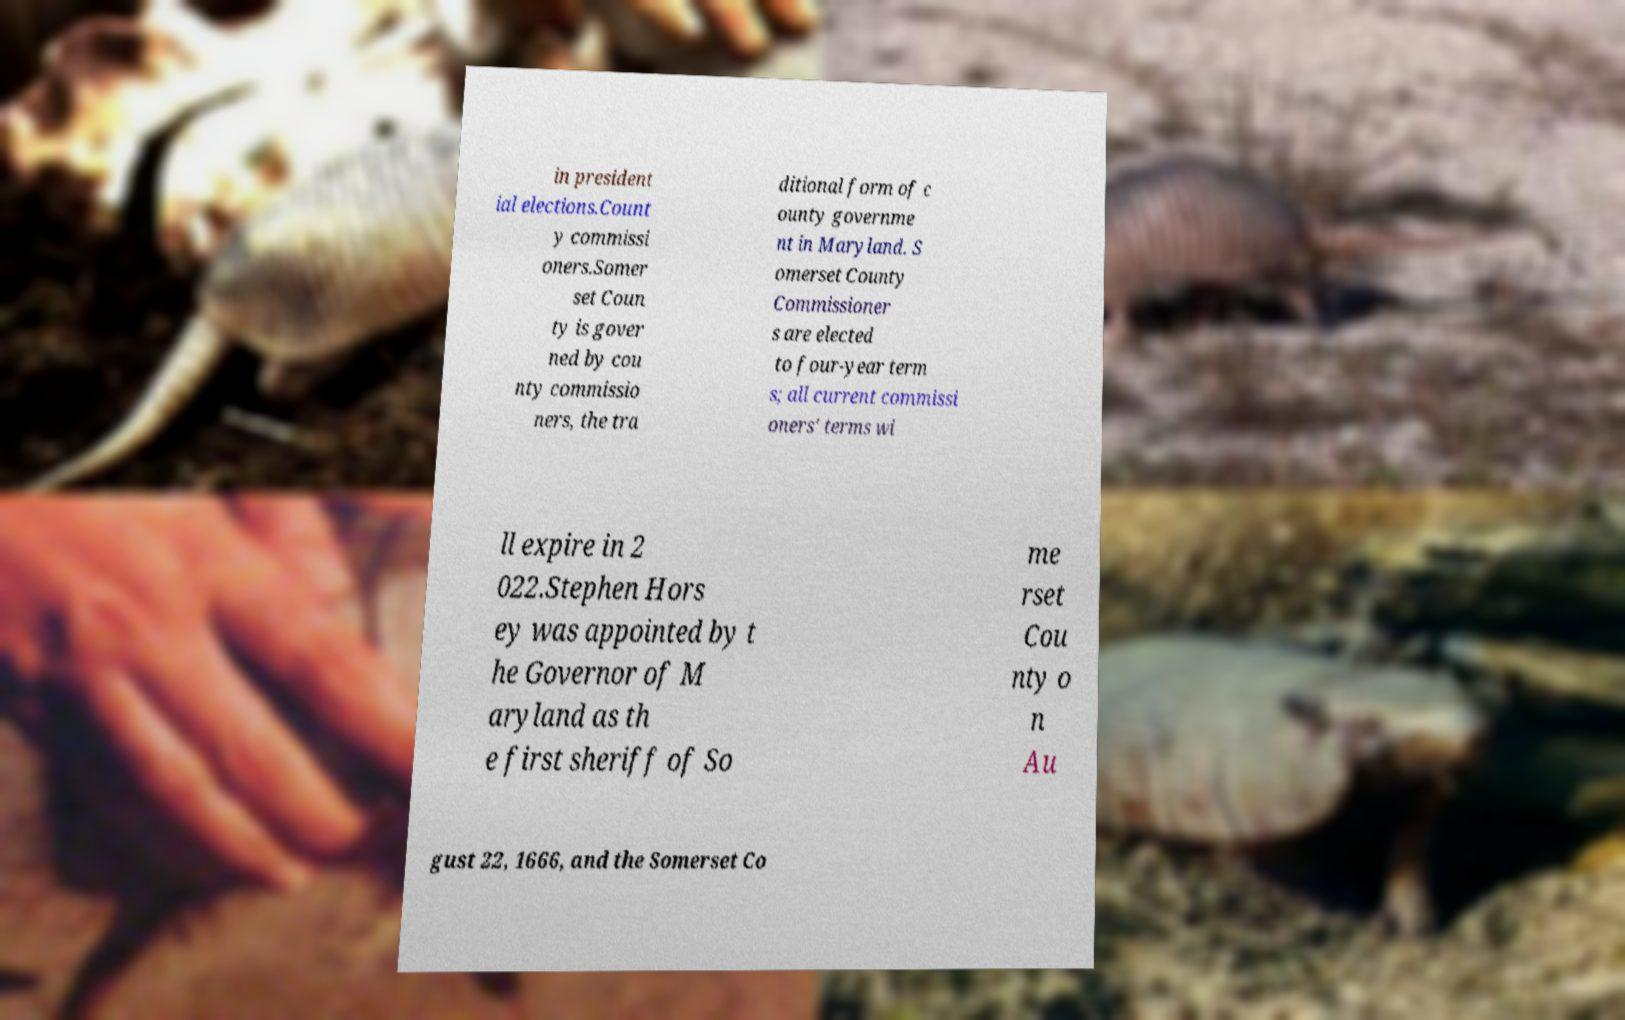Can you read and provide the text displayed in the image?This photo seems to have some interesting text. Can you extract and type it out for me? in president ial elections.Count y commissi oners.Somer set Coun ty is gover ned by cou nty commissio ners, the tra ditional form of c ounty governme nt in Maryland. S omerset County Commissioner s are elected to four-year term s; all current commissi oners' terms wi ll expire in 2 022.Stephen Hors ey was appointed by t he Governor of M aryland as th e first sheriff of So me rset Cou nty o n Au gust 22, 1666, and the Somerset Co 